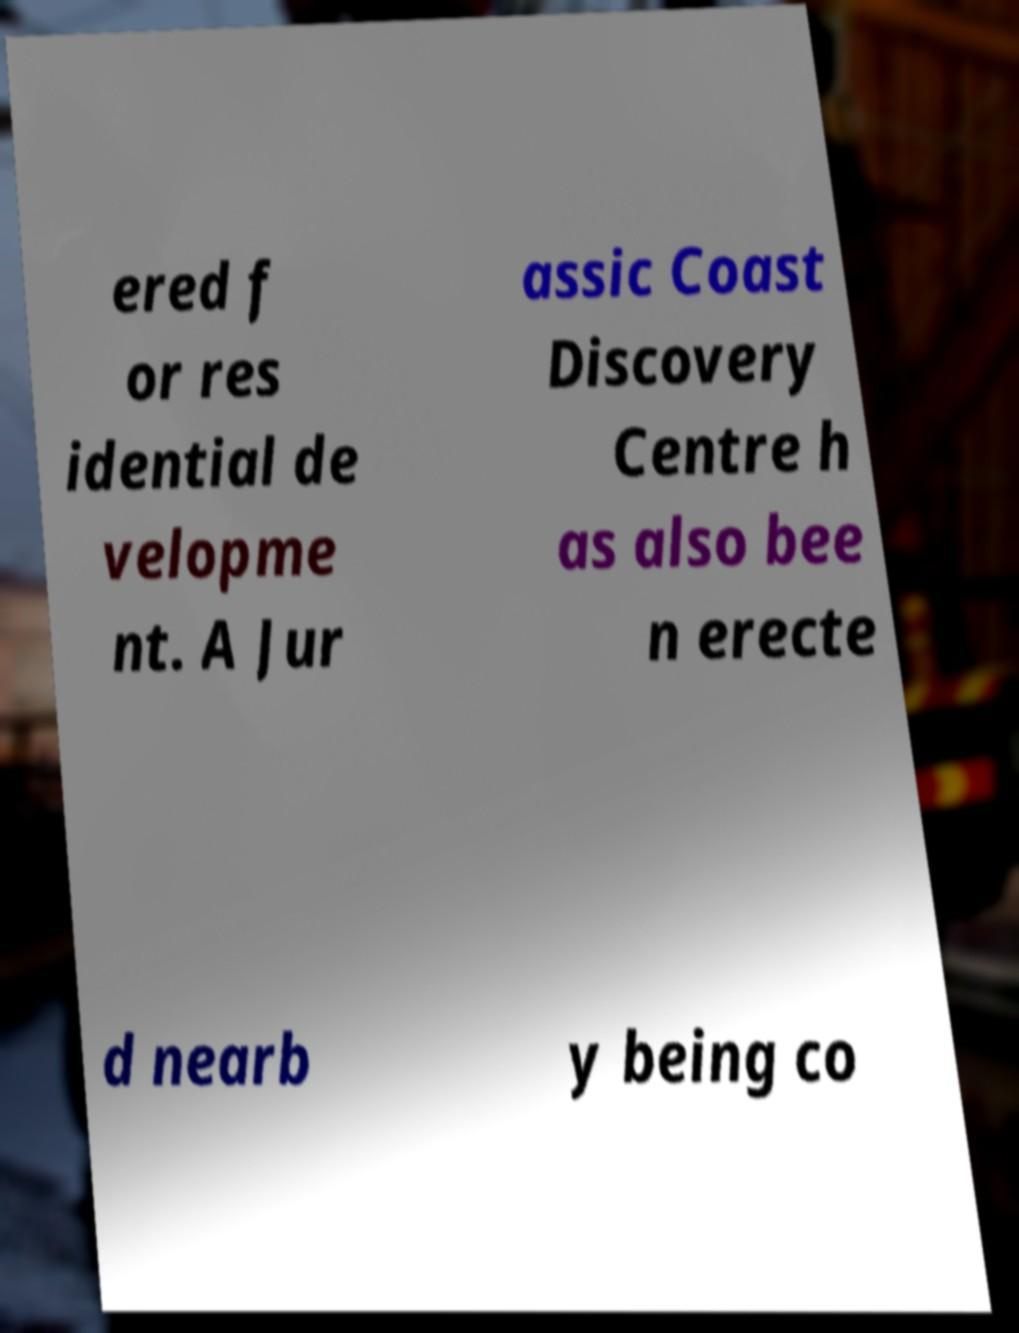Please read and relay the text visible in this image. What does it say? ered f or res idential de velopme nt. A Jur assic Coast Discovery Centre h as also bee n erecte d nearb y being co 